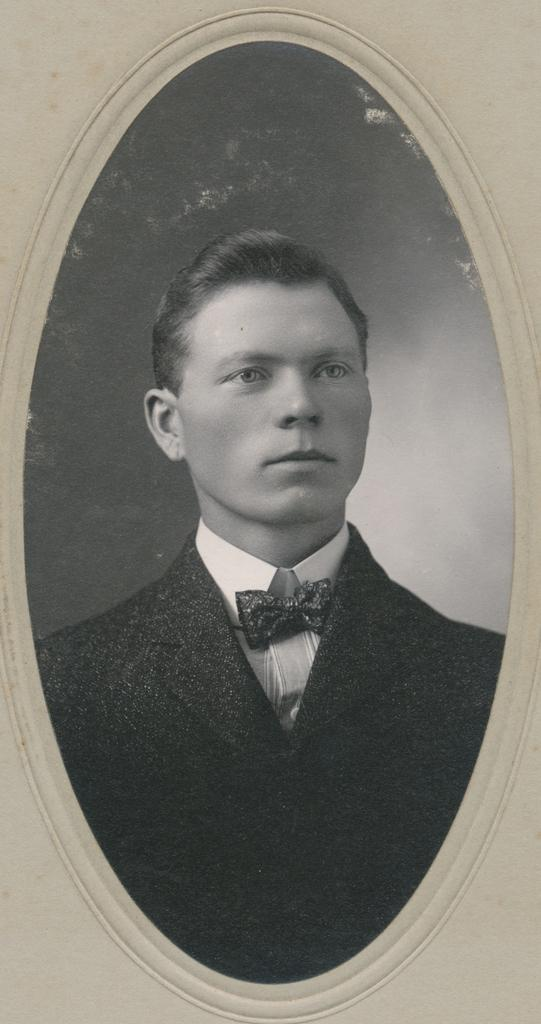What is the main object in the image? There is a frame in the image. What can be seen inside the frame? Inside the frame, there is a man. What is the man wearing on his upper body? The man is wearing a blazer. What type of neckwear is the man wearing? The man is wearing a bow tie. What appliance is the man using to balance in the image? There is no appliance present in the image, nor is the man balancing on anything. 